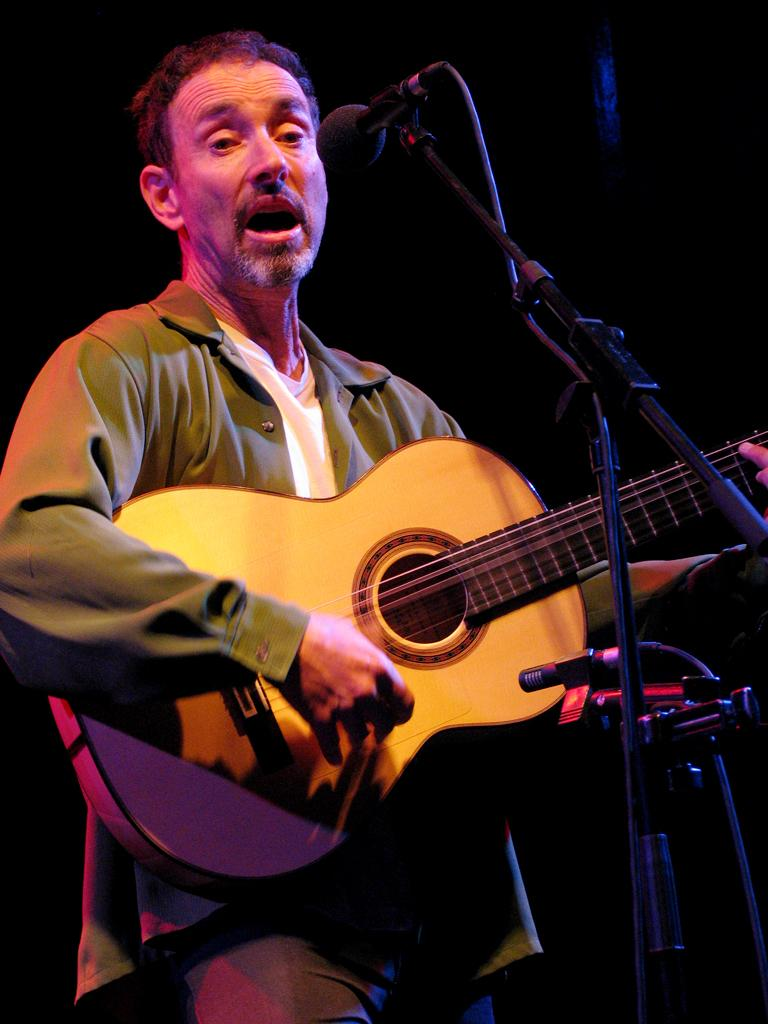What is happening in the image? It is a concert. What instrument is the man playing? The man is playing a guitar. What is the man doing while playing the guitar? The man is singing a song. What is the man using to amplify his voice? There is a microphone in front of the man. How would you describe the lighting in the image? The background is dark. What type of meal is being served at the park in the image? There is no park or meal present in the image; it is a concert with a man playing a guitar and singing. 